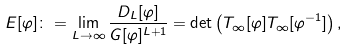Convert formula to latex. <formula><loc_0><loc_0><loc_500><loc_500>E [ \varphi ] \colon = \lim _ { L \to \infty } \frac { D _ { L } [ \varphi ] } { G [ \varphi ] ^ { L + 1 } } = \det \left ( T _ { \infty } [ \varphi ] T _ { \infty } [ \varphi ^ { - 1 } ] \right ) ,</formula> 